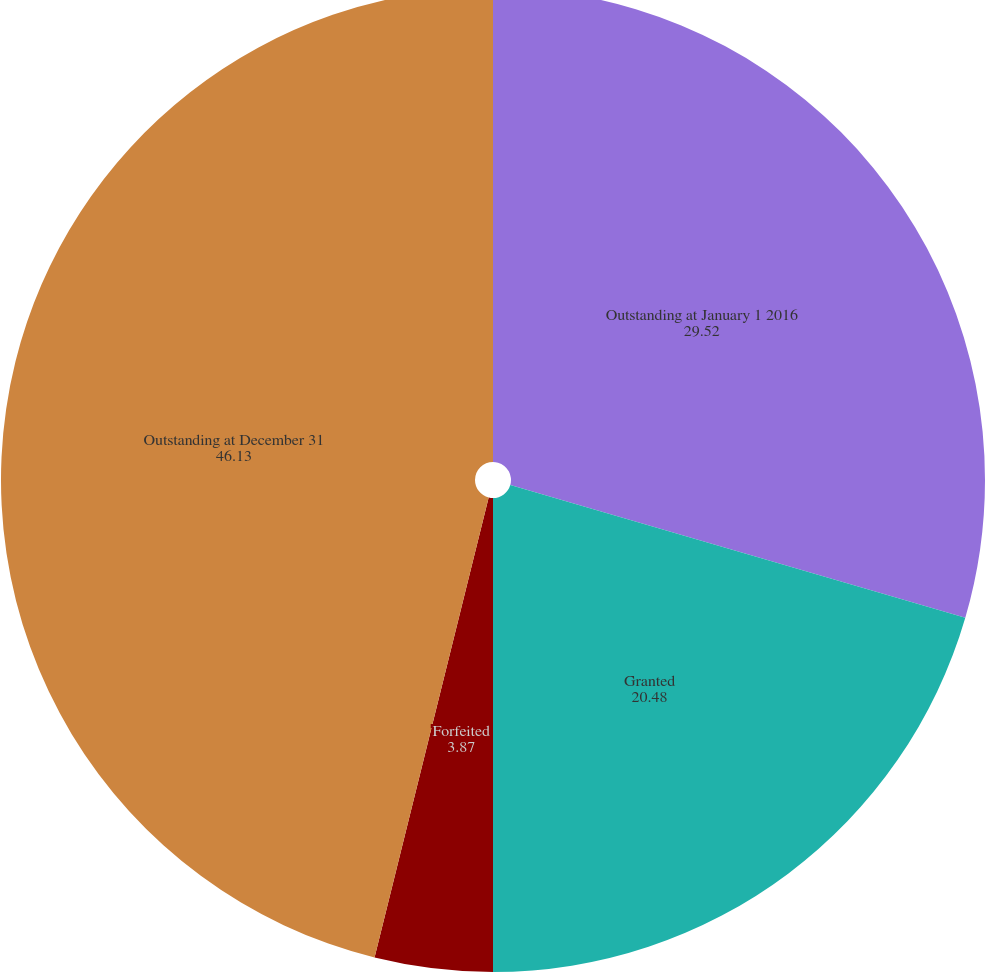Convert chart to OTSL. <chart><loc_0><loc_0><loc_500><loc_500><pie_chart><fcel>Outstanding at January 1 2016<fcel>Granted<fcel>Forfeited<fcel>Outstanding at December 31<nl><fcel>29.52%<fcel>20.48%<fcel>3.87%<fcel>46.13%<nl></chart> 